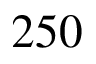<formula> <loc_0><loc_0><loc_500><loc_500>2 5 0</formula> 